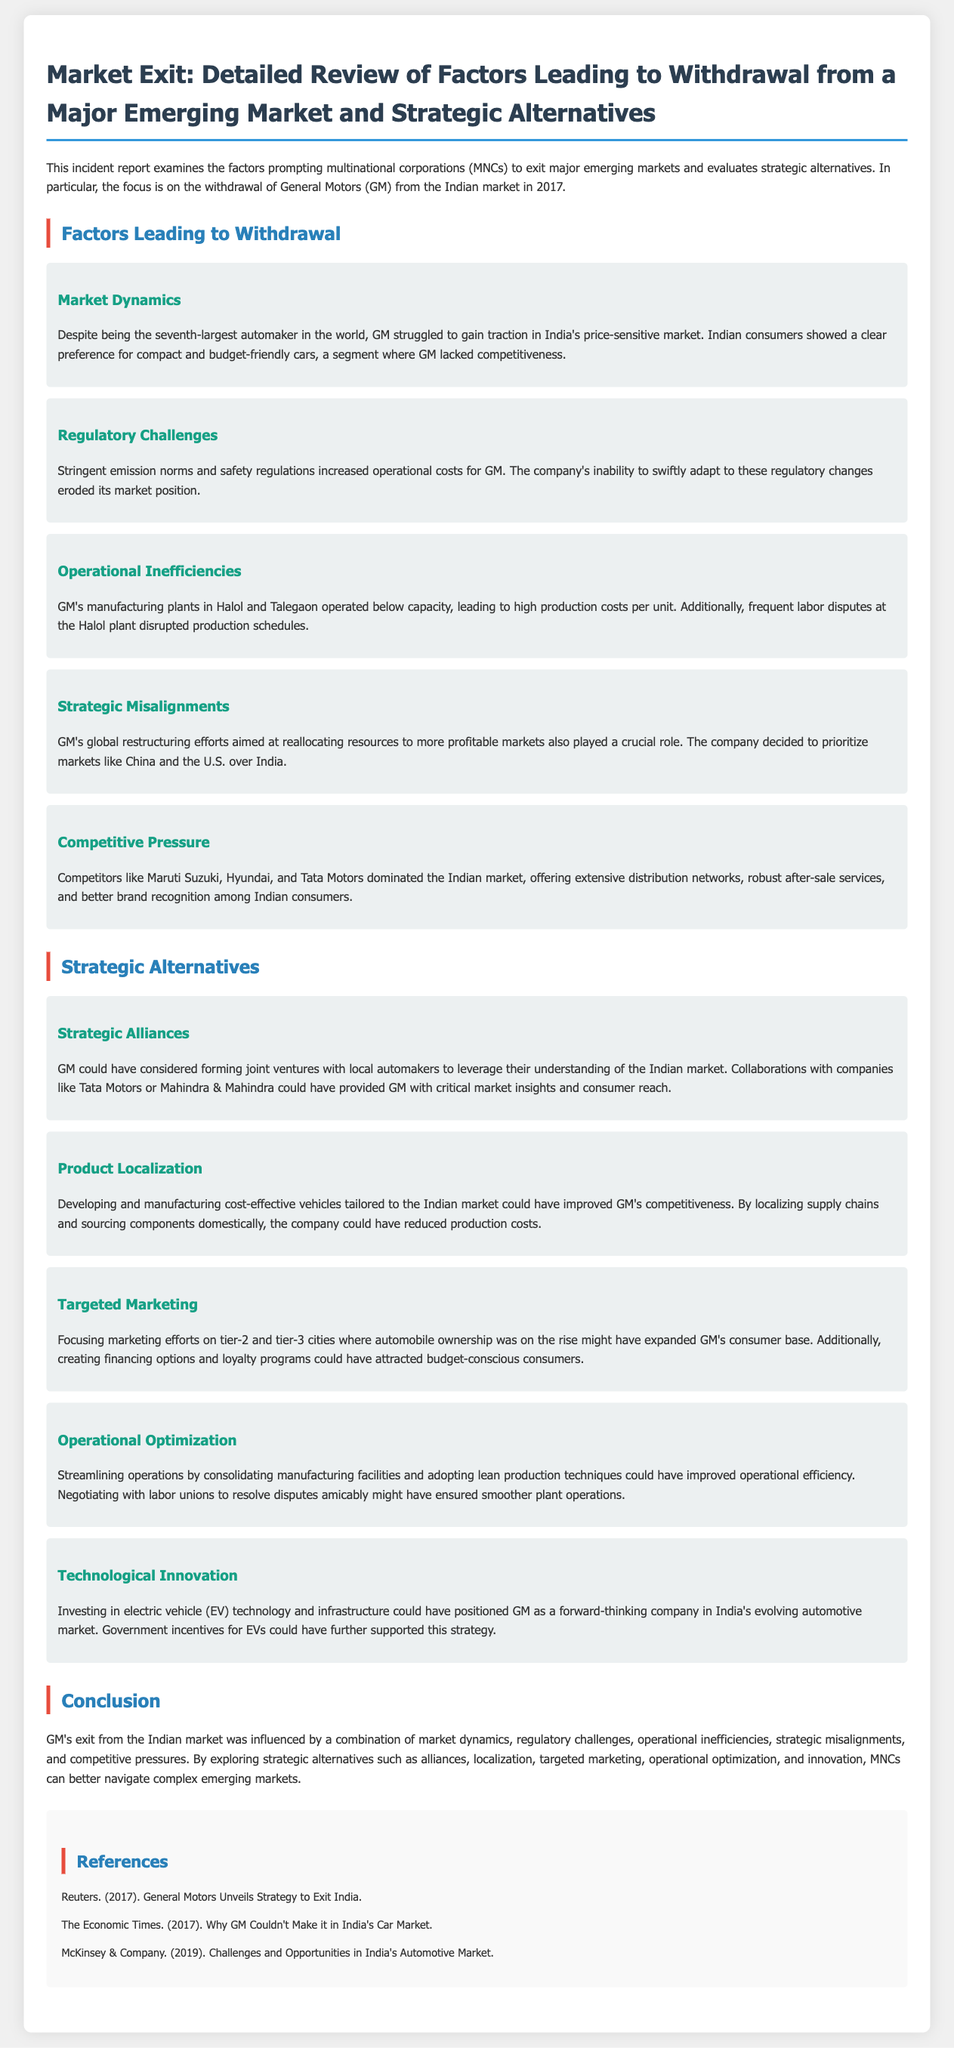what year did GM withdraw from India? The document states that GM’s withdrawal occurred in 2017.
Answer: 2017 what were the two manufacturing plants mentioned? The document refers to GM's manufacturing plants located in Halol and Talegaon.
Answer: Halol and Talegaon which companies dominated the Indian market? The report lists Maruti Suzuki, Hyundai, and Tata Motors as the main competitors in the Indian market.
Answer: Maruti Suzuki, Hyundai, and Tata Motors what is one strategic alternative mentioned for GM? The document suggests that one strategic alternative could be forming joint ventures with local automakers.
Answer: Strategic alliances what is the primary reason GM struggled in India? The document mentions that GM struggled in India's price-sensitive market.
Answer: Price-sensitive market which type of vehicle technology could GM invest in? The report discusses investing in electric vehicle technology as a forward-thinking strategy.
Answer: Electric vehicle technology what operational issue did GM face at its Halol plant? The document indicates that frequent labor disputes disrupted production schedules at the Halol plant.
Answer: Labor disputes which market was GM prioritizing over India? The report states that GM decided to prioritize markets like China and the U.S. over India.
Answer: China and the U.S what regulatory challenge increased GM's operational costs? The document identifies stringent emission norms and safety regulations as a challenge.
Answer: Stringent emission norms and safety regulations 